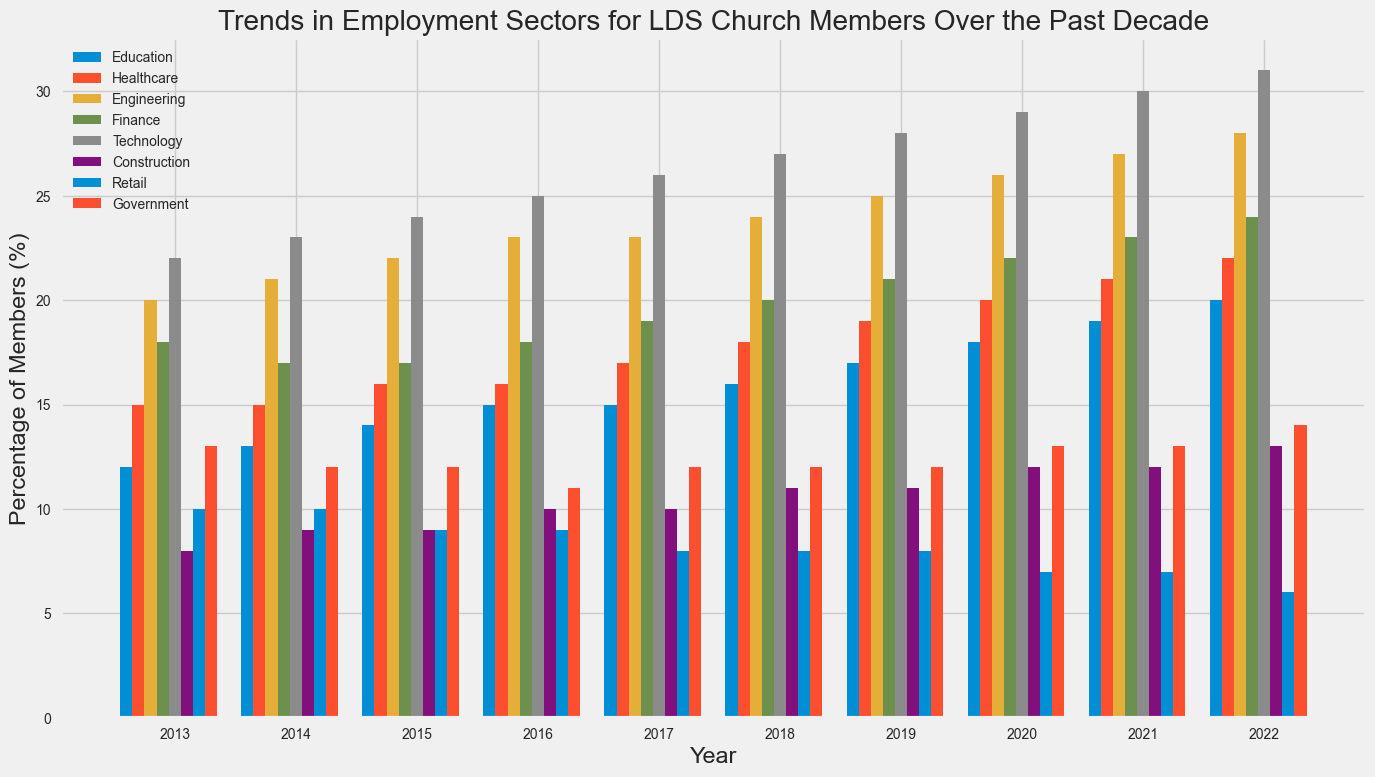What employment sector shows the greatest increase in percentage of members from 2013 to 2022? Look at the heights of the bars from 2013 to 2022 for each sector. Technology shows a clear growth trend, starting at 22% in 2013 and rising to 31% in 2022.
Answer: Technology Which two sectors had the most significant declines in percentage of members over the decade? Compare the heights of the bars from 2013 to 2022 for each sector. Construction declines from 8% to 6%, and Retail declines from 10% to 6%.
Answer: Construction and Retail In 2022, which two sectors had the exact same percentage of members? In 2022, look for bars that are of equal height. The bars for Finance and Healthcare are both at 24%.
Answer: Healthcare and Finance How many sectors had a steady increase (no declines) over the period 2013-2022? Count the sectors where the bars increase every year without any decline. This applies for Education, Healthcare, Engineering, Finance, and Technology, making a total of 5.
Answer: 5 sectors What is the average percentage of members in the Government sector over the decade? Sum the percentages for the Government sector from 2013 to 2022 and divide by the number of years (10). The values are 13, 12, 12, 11, 12, 12, 12, 13, 13, and 14. The total is 124, so the average is 124/10 = 12.4%
Answer: 12.4% Which sector had the highest percentage of members in 2016? Look at the top bar in 2016. Technology has the highest percentage at 25%.
Answer: Technology By what percentage did the Education sector increase from 2013 to 2022? Subtract the 2013 value from the 2022 value for Education. The values are 20% in 2022 and 12% in 2013. The difference is 20 - 12 = 8%.
Answer: 8% What is the difference in percentage of members between Technology and Construction in 2020? Find and subtract the values for Technology and Construction in 2020. Technology is at 29%, and Construction is at 12%. The difference is 29 - 12 = 17%.
Answer: 17% Which sector had no change in member percentage from 2017 to 2022? Compare the bars for the sectors from 2017 to 2022 and see which remains unchanged. The Government sector stays at 12%.
Answer: Government In 2015, which sector had a member percentage closest to the median value among all sectors? List the percentages for all sectors in 2015: 14, 16, 22, 17, 24, 9, 9, 12. Arrange them in order: 9, 9, 12, 14, 16, 17, 22, 24. The median is between 14 and 16, so it’s closest to 14 (Education).
Answer: Education 